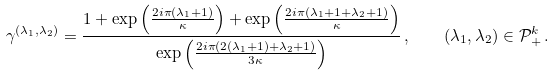Convert formula to latex. <formula><loc_0><loc_0><loc_500><loc_500>\gamma ^ { ( \lambda _ { 1 } , \lambda _ { 2 } ) } = \frac { 1 + \exp \left ( \frac { 2 i \pi ( \lambda _ { 1 } + 1 ) } { \kappa } \right ) + \exp \left ( \frac { 2 i \pi ( \lambda _ { 1 } + 1 + \lambda _ { 2 } + 1 ) } { \kappa } \right ) } { \exp \left ( \frac { 2 i \pi ( 2 ( \lambda _ { 1 } + 1 ) + \lambda _ { 2 } + 1 ) } { 3 \kappa } \right ) } \, , \quad ( \lambda _ { 1 } , \lambda _ { 2 } ) \in \mathcal { P } _ { + } ^ { k } \, .</formula> 